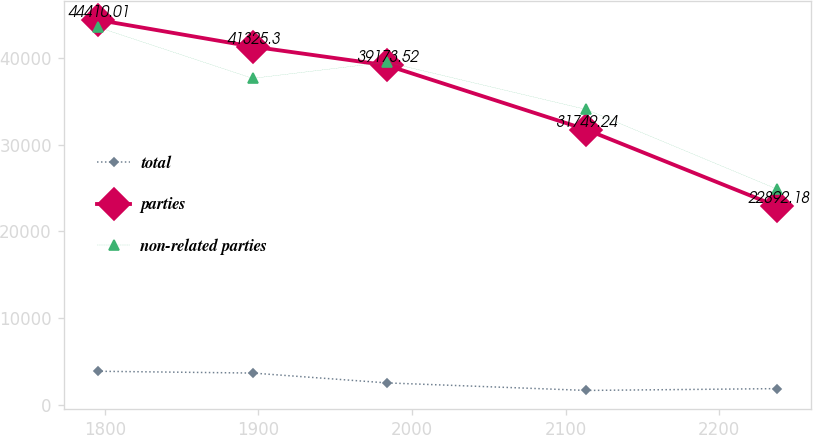Convert chart to OTSL. <chart><loc_0><loc_0><loc_500><loc_500><line_chart><ecel><fcel>total<fcel>parties<fcel>non-related parties<nl><fcel>1795.24<fcel>3863.63<fcel>44410<fcel>43582<nl><fcel>1896.25<fcel>3654.88<fcel>41325.3<fcel>37662<nl><fcel>1983.48<fcel>2521.01<fcel>39173.5<fcel>39533.2<nl><fcel>2113.5<fcel>1650.01<fcel>31749.2<fcel>34071<nl><fcel>2237.86<fcel>1858.76<fcel>22892.2<fcel>24869.4<nl></chart> 